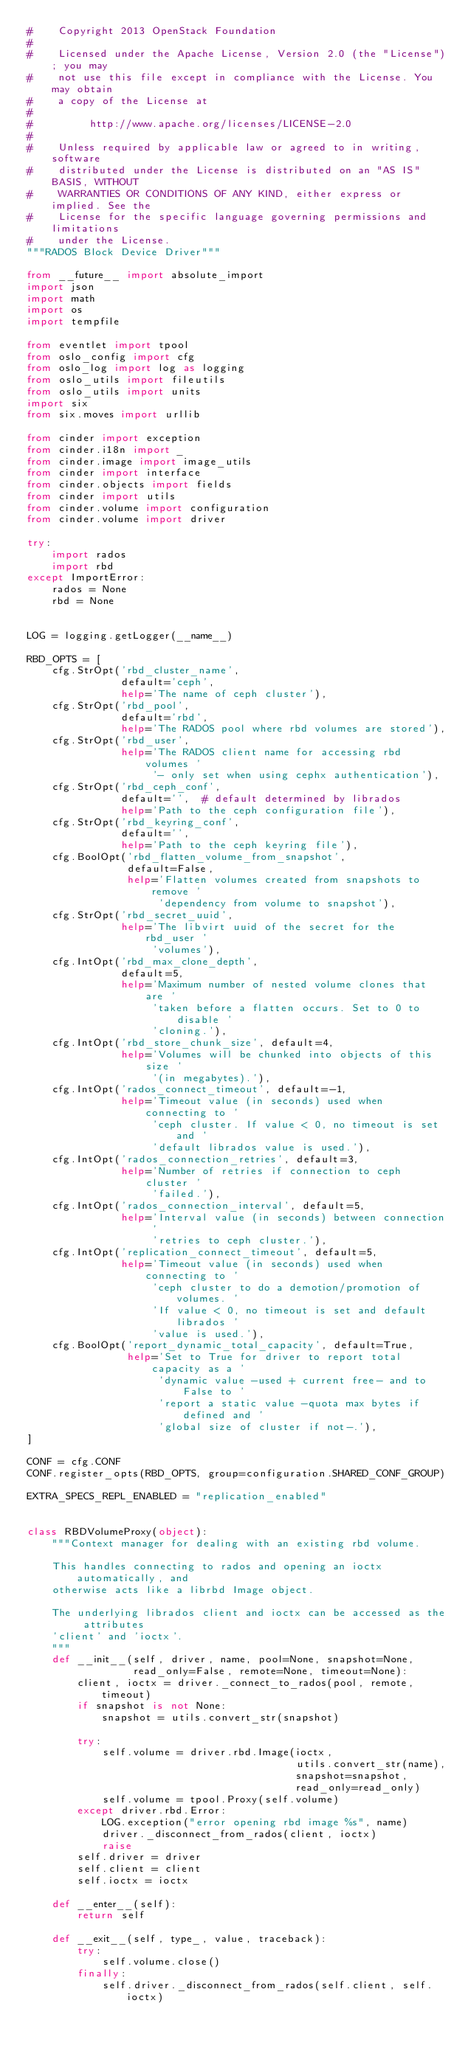Convert code to text. <code><loc_0><loc_0><loc_500><loc_500><_Python_>#    Copyright 2013 OpenStack Foundation
#
#    Licensed under the Apache License, Version 2.0 (the "License"); you may
#    not use this file except in compliance with the License. You may obtain
#    a copy of the License at
#
#         http://www.apache.org/licenses/LICENSE-2.0
#
#    Unless required by applicable law or agreed to in writing, software
#    distributed under the License is distributed on an "AS IS" BASIS, WITHOUT
#    WARRANTIES OR CONDITIONS OF ANY KIND, either express or implied. See the
#    License for the specific language governing permissions and limitations
#    under the License.
"""RADOS Block Device Driver"""

from __future__ import absolute_import
import json
import math
import os
import tempfile

from eventlet import tpool
from oslo_config import cfg
from oslo_log import log as logging
from oslo_utils import fileutils
from oslo_utils import units
import six
from six.moves import urllib

from cinder import exception
from cinder.i18n import _
from cinder.image import image_utils
from cinder import interface
from cinder.objects import fields
from cinder import utils
from cinder.volume import configuration
from cinder.volume import driver

try:
    import rados
    import rbd
except ImportError:
    rados = None
    rbd = None


LOG = logging.getLogger(__name__)

RBD_OPTS = [
    cfg.StrOpt('rbd_cluster_name',
               default='ceph',
               help='The name of ceph cluster'),
    cfg.StrOpt('rbd_pool',
               default='rbd',
               help='The RADOS pool where rbd volumes are stored'),
    cfg.StrOpt('rbd_user',
               help='The RADOS client name for accessing rbd volumes '
                    '- only set when using cephx authentication'),
    cfg.StrOpt('rbd_ceph_conf',
               default='',  # default determined by librados
               help='Path to the ceph configuration file'),
    cfg.StrOpt('rbd_keyring_conf',
               default='',
               help='Path to the ceph keyring file'),
    cfg.BoolOpt('rbd_flatten_volume_from_snapshot',
                default=False,
                help='Flatten volumes created from snapshots to remove '
                     'dependency from volume to snapshot'),
    cfg.StrOpt('rbd_secret_uuid',
               help='The libvirt uuid of the secret for the rbd_user '
                    'volumes'),
    cfg.IntOpt('rbd_max_clone_depth',
               default=5,
               help='Maximum number of nested volume clones that are '
                    'taken before a flatten occurs. Set to 0 to disable '
                    'cloning.'),
    cfg.IntOpt('rbd_store_chunk_size', default=4,
               help='Volumes will be chunked into objects of this size '
                    '(in megabytes).'),
    cfg.IntOpt('rados_connect_timeout', default=-1,
               help='Timeout value (in seconds) used when connecting to '
                    'ceph cluster. If value < 0, no timeout is set and '
                    'default librados value is used.'),
    cfg.IntOpt('rados_connection_retries', default=3,
               help='Number of retries if connection to ceph cluster '
                    'failed.'),
    cfg.IntOpt('rados_connection_interval', default=5,
               help='Interval value (in seconds) between connection '
                    'retries to ceph cluster.'),
    cfg.IntOpt('replication_connect_timeout', default=5,
               help='Timeout value (in seconds) used when connecting to '
                    'ceph cluster to do a demotion/promotion of volumes. '
                    'If value < 0, no timeout is set and default librados '
                    'value is used.'),
    cfg.BoolOpt('report_dynamic_total_capacity', default=True,
                help='Set to True for driver to report total capacity as a '
                     'dynamic value -used + current free- and to False to '
                     'report a static value -quota max bytes if defined and '
                     'global size of cluster if not-.'),
]

CONF = cfg.CONF
CONF.register_opts(RBD_OPTS, group=configuration.SHARED_CONF_GROUP)

EXTRA_SPECS_REPL_ENABLED = "replication_enabled"


class RBDVolumeProxy(object):
    """Context manager for dealing with an existing rbd volume.

    This handles connecting to rados and opening an ioctx automatically, and
    otherwise acts like a librbd Image object.

    The underlying librados client and ioctx can be accessed as the attributes
    'client' and 'ioctx'.
    """
    def __init__(self, driver, name, pool=None, snapshot=None,
                 read_only=False, remote=None, timeout=None):
        client, ioctx = driver._connect_to_rados(pool, remote, timeout)
        if snapshot is not None:
            snapshot = utils.convert_str(snapshot)

        try:
            self.volume = driver.rbd.Image(ioctx,
                                           utils.convert_str(name),
                                           snapshot=snapshot,
                                           read_only=read_only)
            self.volume = tpool.Proxy(self.volume)
        except driver.rbd.Error:
            LOG.exception("error opening rbd image %s", name)
            driver._disconnect_from_rados(client, ioctx)
            raise
        self.driver = driver
        self.client = client
        self.ioctx = ioctx

    def __enter__(self):
        return self

    def __exit__(self, type_, value, traceback):
        try:
            self.volume.close()
        finally:
            self.driver._disconnect_from_rados(self.client, self.ioctx)
</code> 